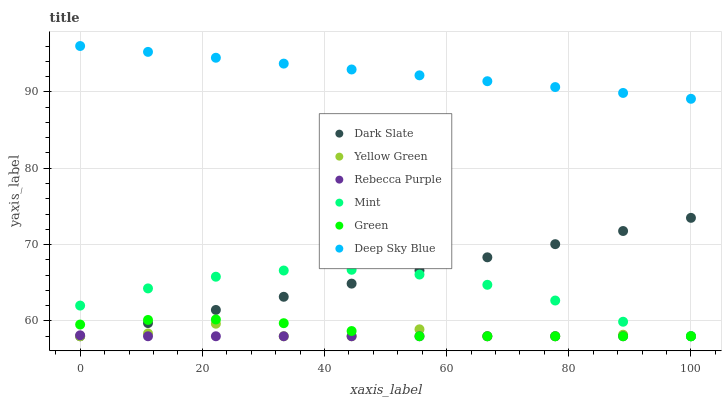Does Rebecca Purple have the minimum area under the curve?
Answer yes or no. Yes. Does Deep Sky Blue have the maximum area under the curve?
Answer yes or no. Yes. Does Dark Slate have the minimum area under the curve?
Answer yes or no. No. Does Dark Slate have the maximum area under the curve?
Answer yes or no. No. Is Dark Slate the smoothest?
Answer yes or no. Yes. Is Yellow Green the roughest?
Answer yes or no. Yes. Is Green the smoothest?
Answer yes or no. No. Is Green the roughest?
Answer yes or no. No. Does Yellow Green have the lowest value?
Answer yes or no. Yes. Does Deep Sky Blue have the lowest value?
Answer yes or no. No. Does Deep Sky Blue have the highest value?
Answer yes or no. Yes. Does Dark Slate have the highest value?
Answer yes or no. No. Is Rebecca Purple less than Deep Sky Blue?
Answer yes or no. Yes. Is Deep Sky Blue greater than Yellow Green?
Answer yes or no. Yes. Does Dark Slate intersect Rebecca Purple?
Answer yes or no. Yes. Is Dark Slate less than Rebecca Purple?
Answer yes or no. No. Is Dark Slate greater than Rebecca Purple?
Answer yes or no. No. Does Rebecca Purple intersect Deep Sky Blue?
Answer yes or no. No. 